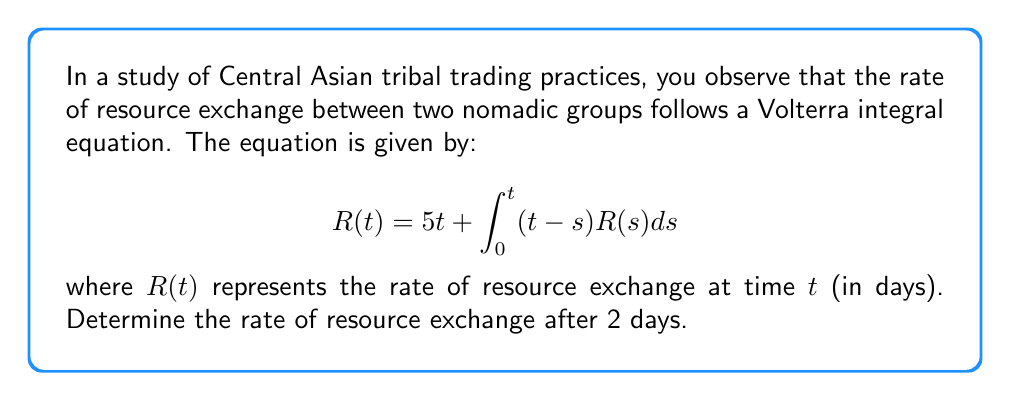Show me your answer to this math problem. To solve this Volterra integral equation, we'll use the method of successive approximations:

1) Start with the initial approximation $R_0(t) = 5t$

2) Substitute this into the integral equation to get the next approximation:

   $$R_1(t) = 5t + \int_0^t (t-s)(5s)ds$$

3) Evaluate the integral:
   
   $$R_1(t) = 5t + 5\int_0^t (ts-s^2)ds = 5t + 5[\frac{1}{2}t^2s - \frac{1}{3}s^3]_0^t = 5t + \frac{5}{2}t^3 - \frac{5}{3}t^3 = 5t + \frac{5}{6}t^3$$

4) For better accuracy, we can iterate once more:

   $$R_2(t) = 5t + \int_0^t (t-s)(5s + \frac{5}{6}s^3)ds$$

5) Evaluate this integral:
   
   $$R_2(t) = 5t + 5\int_0^t (ts-s^2)ds + \frac{5}{6}\int_0^t (ts^3-s^4)ds$$
   $$= 5t + (5\cdot\frac{1}{6}t^3) + \frac{5}{6}(\frac{1}{4}t^4 - \frac{1}{5}t^5)$$
   $$= 5t + \frac{5}{6}t^3 + \frac{5}{24}t^4 - \frac{1}{6}t^5$$

6) Now, we can evaluate $R_2(2)$ to get the rate after 2 days:

   $$R_2(2) = 5(2) + \frac{5}{6}(2^3) + \frac{5}{24}(2^4) - \frac{1}{6}(2^5)$$
   $$= 10 + \frac{40}{6} + \frac{80}{24} - \frac{32}{6}$$
   $$= 10 + 6.67 + 3.33 - 5.33$$
   $$\approx 14.67$$

Therefore, the rate of resource exchange after 2 days is approximately 14.67 units per day.
Answer: $14.67$ units/day 